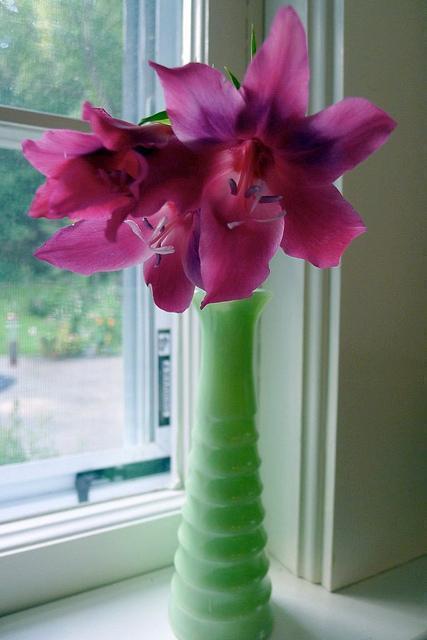How many flowers in the vase?
Give a very brief answer. 2. How many people are wearing red shirts?
Give a very brief answer. 0. 